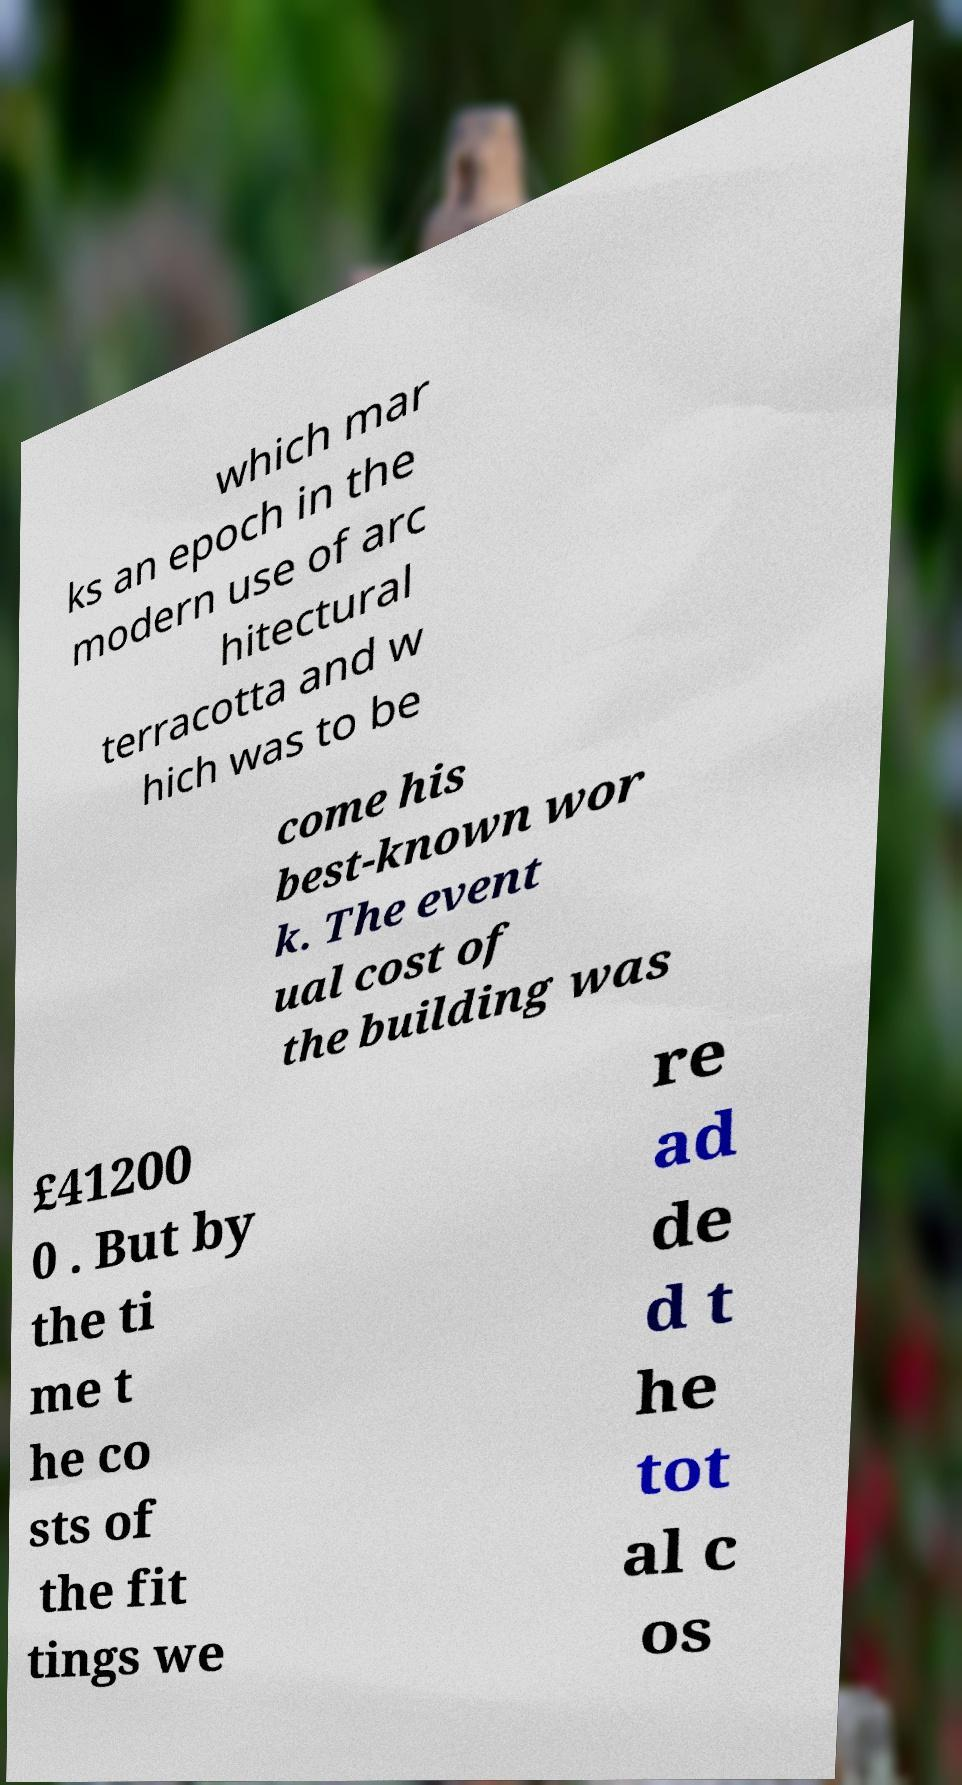Could you extract and type out the text from this image? which mar ks an epoch in the modern use of arc hitectural terracotta and w hich was to be come his best-known wor k. The event ual cost of the building was £41200 0 . But by the ti me t he co sts of the fit tings we re ad de d t he tot al c os 